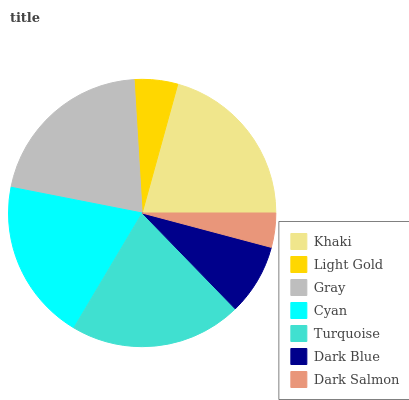Is Dark Salmon the minimum?
Answer yes or no. Yes. Is Gray the maximum?
Answer yes or no. Yes. Is Light Gold the minimum?
Answer yes or no. No. Is Light Gold the maximum?
Answer yes or no. No. Is Khaki greater than Light Gold?
Answer yes or no. Yes. Is Light Gold less than Khaki?
Answer yes or no. Yes. Is Light Gold greater than Khaki?
Answer yes or no. No. Is Khaki less than Light Gold?
Answer yes or no. No. Is Cyan the high median?
Answer yes or no. Yes. Is Cyan the low median?
Answer yes or no. Yes. Is Light Gold the high median?
Answer yes or no. No. Is Light Gold the low median?
Answer yes or no. No. 